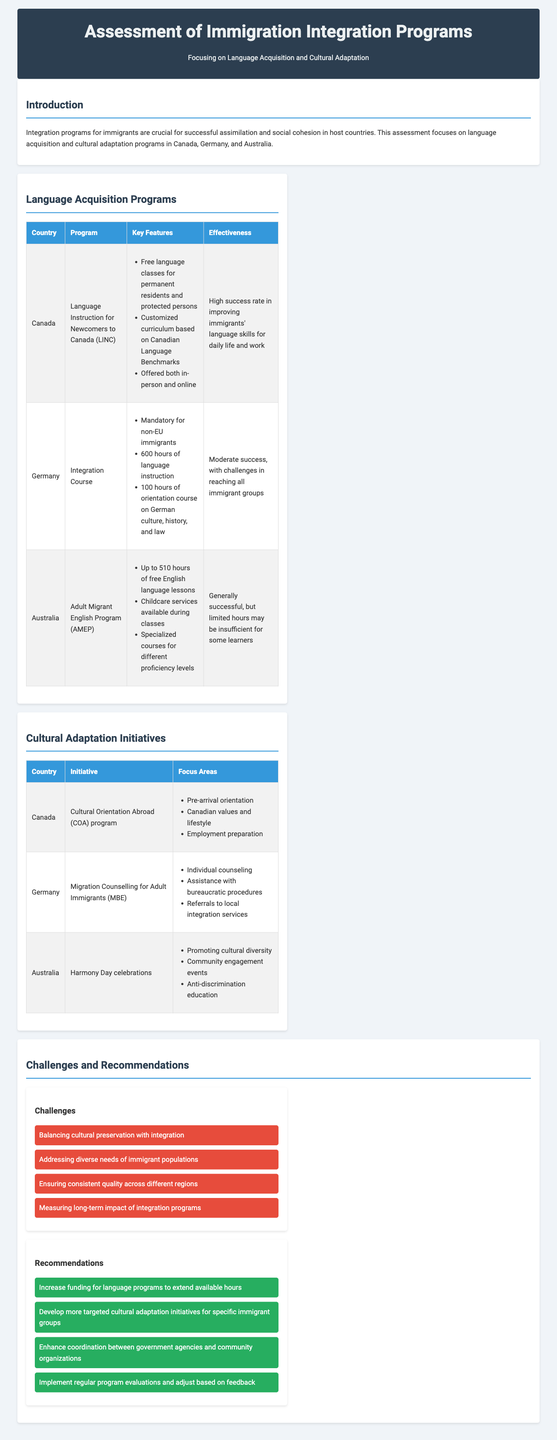What program does Canada offer for language instruction? The program offered by Canada for language instruction is detailed in the Language Acquisition Programs section.
Answer: Language Instruction for Newcomers to Canada (LINC) How many hours of language instruction are required in Germany's Integration Course? The specific number of hours for language instruction in Germany’s Integration Course is stated in the table.
Answer: 600 hours What is a key feature of Australia's Adult Migrant English Program? The key features of the Adult Migrant English Program are listed in the table, highlighting unique aspects of the program.
Answer: Up to 510 hours of free English language lessons What are the focus areas of Canada’s Cultural Orientation Abroad (COA) program? The focus areas of the COA program are outlined in the Cultural Adaptation Initiatives section, detailing what is covered.
Answer: Pre-arrival orientation, Canadian values and lifestyle, Employment preparation Which country has mandatory language instruction for non-EU immigrants? The document specifies which country has made language instruction mandatory for a specific group of immigrants in the Language Acquisition Programs section.
Answer: Germany What is the main challenge regarding the immigrant population mentioned in the Challenges section? A primary challenge listed in the Challenges section relates to the diversity of the immigrant population.
Answer: Addressing diverse needs of immigrant populations What recommendation involves enhancing coordination? The recommendations are provided in their own section, with one specifically addressing coordination efforts.
Answer: Enhance coordination between government agencies and community organizations How does Australia celebrate cultural diversity according to the document? The document describes how Australia promotes cultural diversity through specific initiatives.
Answer: Harmony Day celebrations 